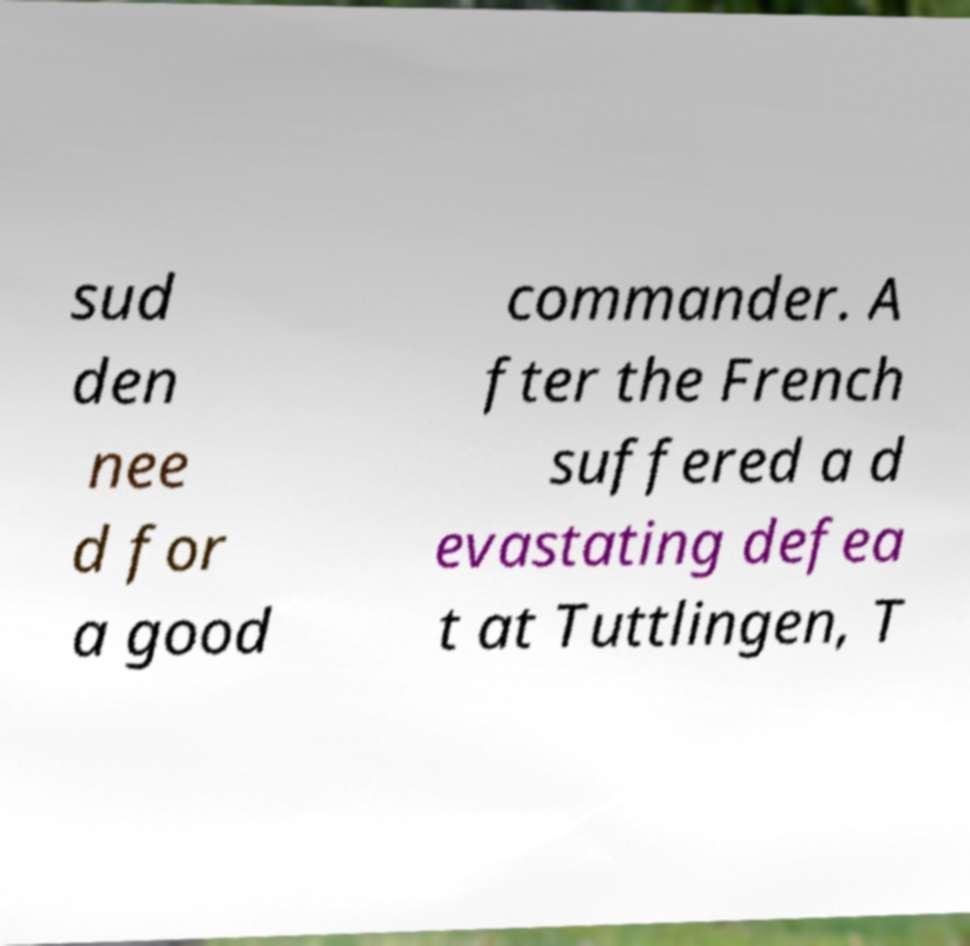What messages or text are displayed in this image? I need them in a readable, typed format. sud den nee d for a good commander. A fter the French suffered a d evastating defea t at Tuttlingen, T 